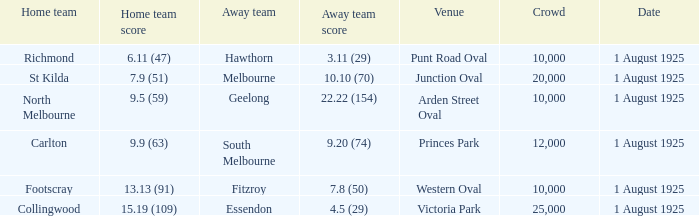At the match where the away team scored 4.5 (29), what was the crowd size? 1.0. 